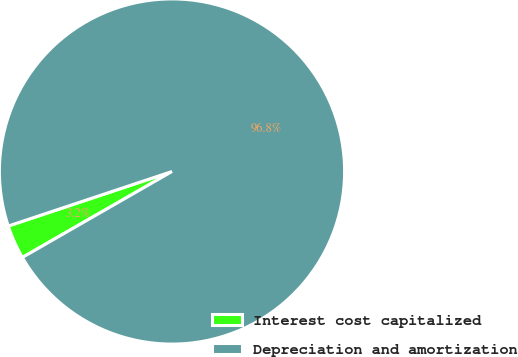<chart> <loc_0><loc_0><loc_500><loc_500><pie_chart><fcel>Interest cost capitalized<fcel>Depreciation and amortization<nl><fcel>3.18%<fcel>96.82%<nl></chart> 